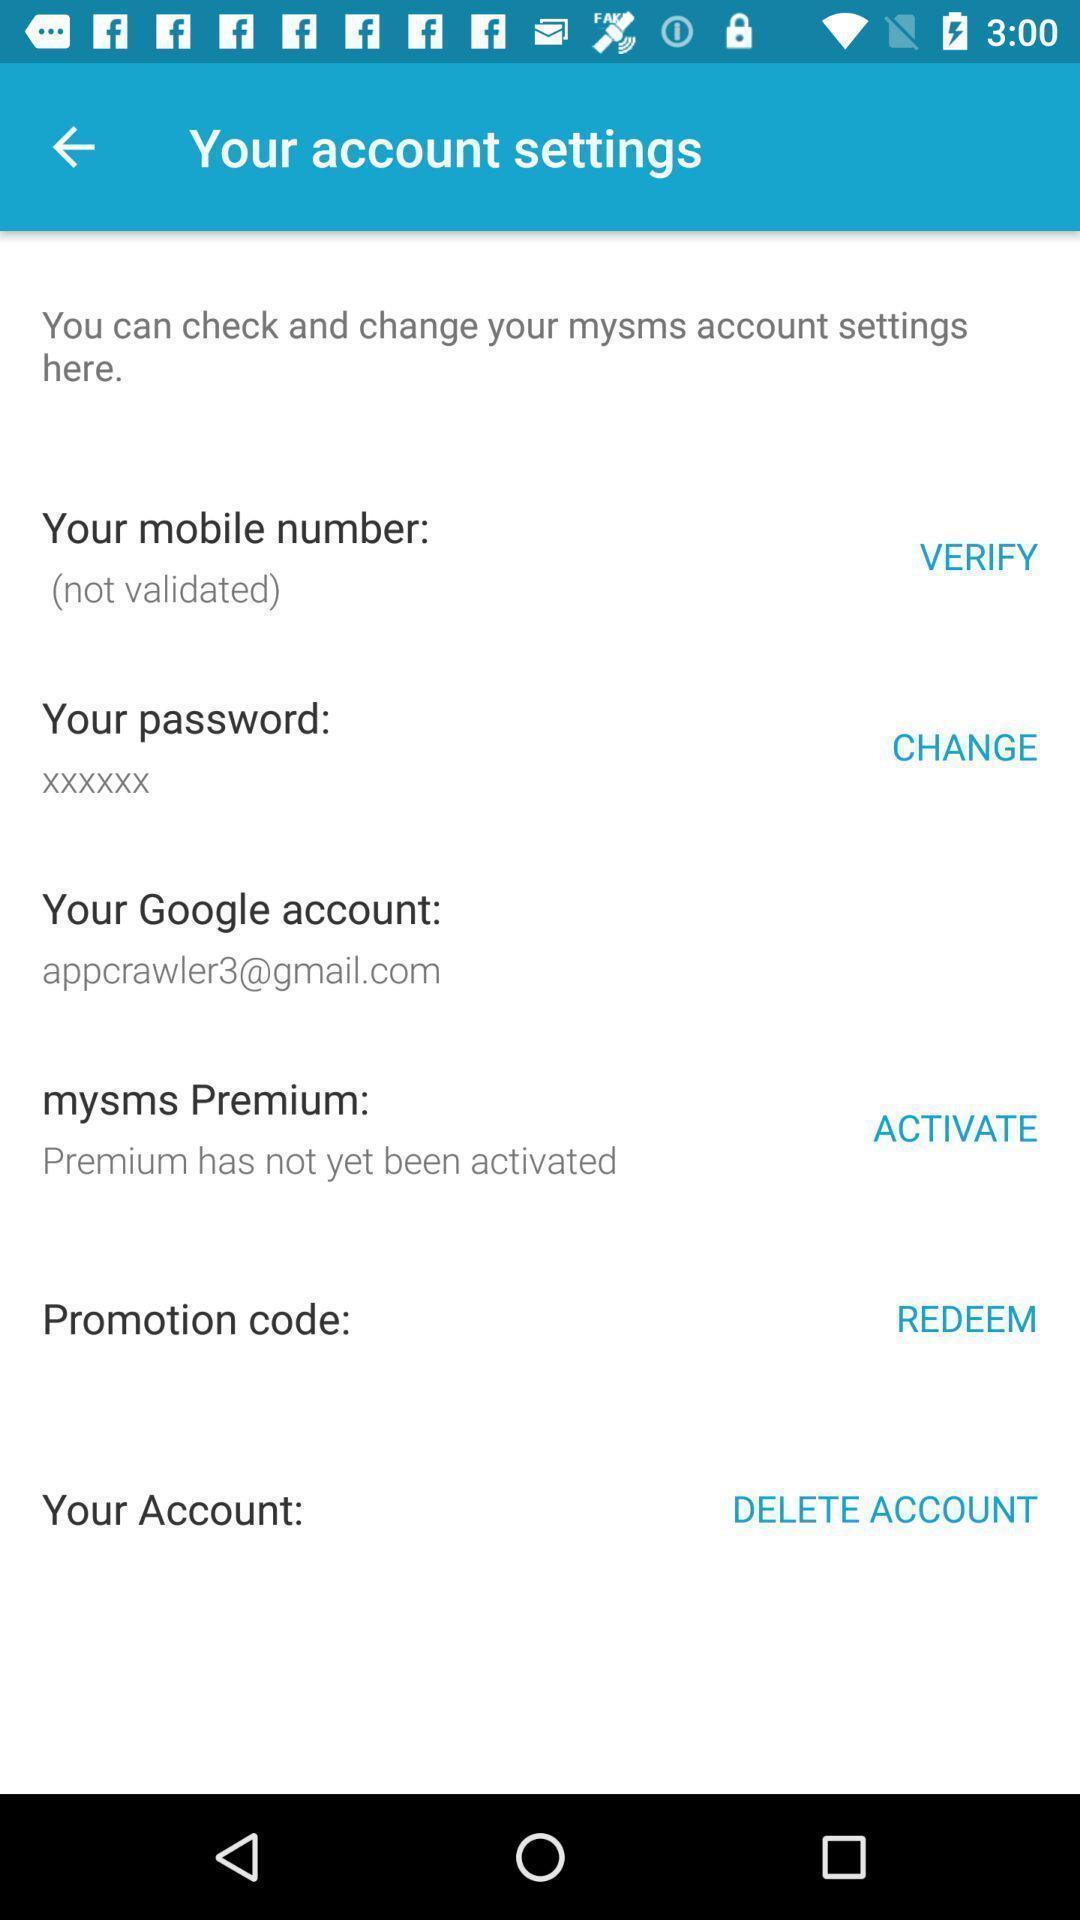Summarize the main components in this picture. Page showing list of phone account settings. 